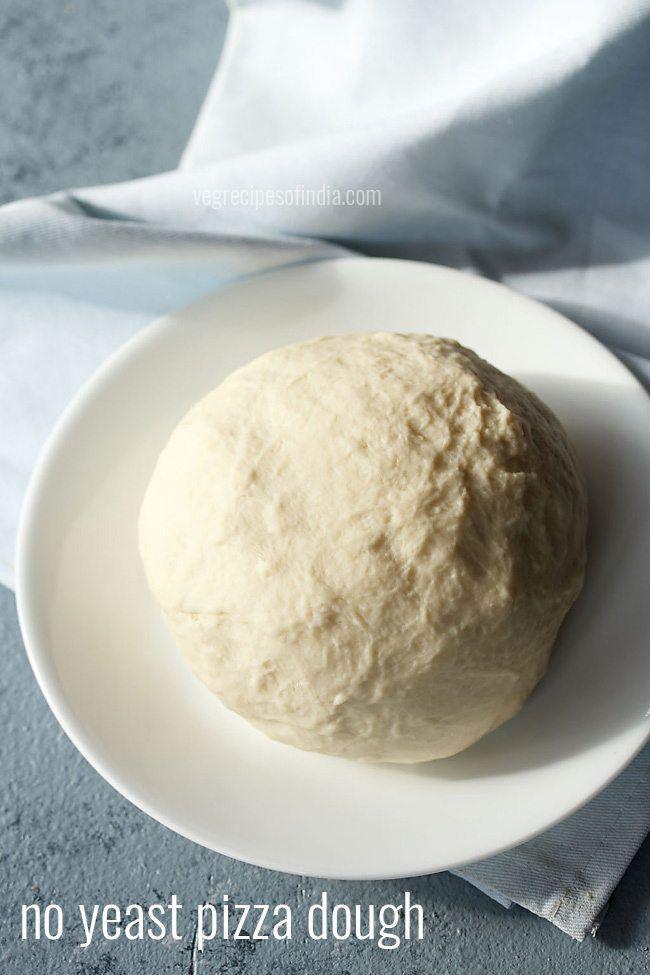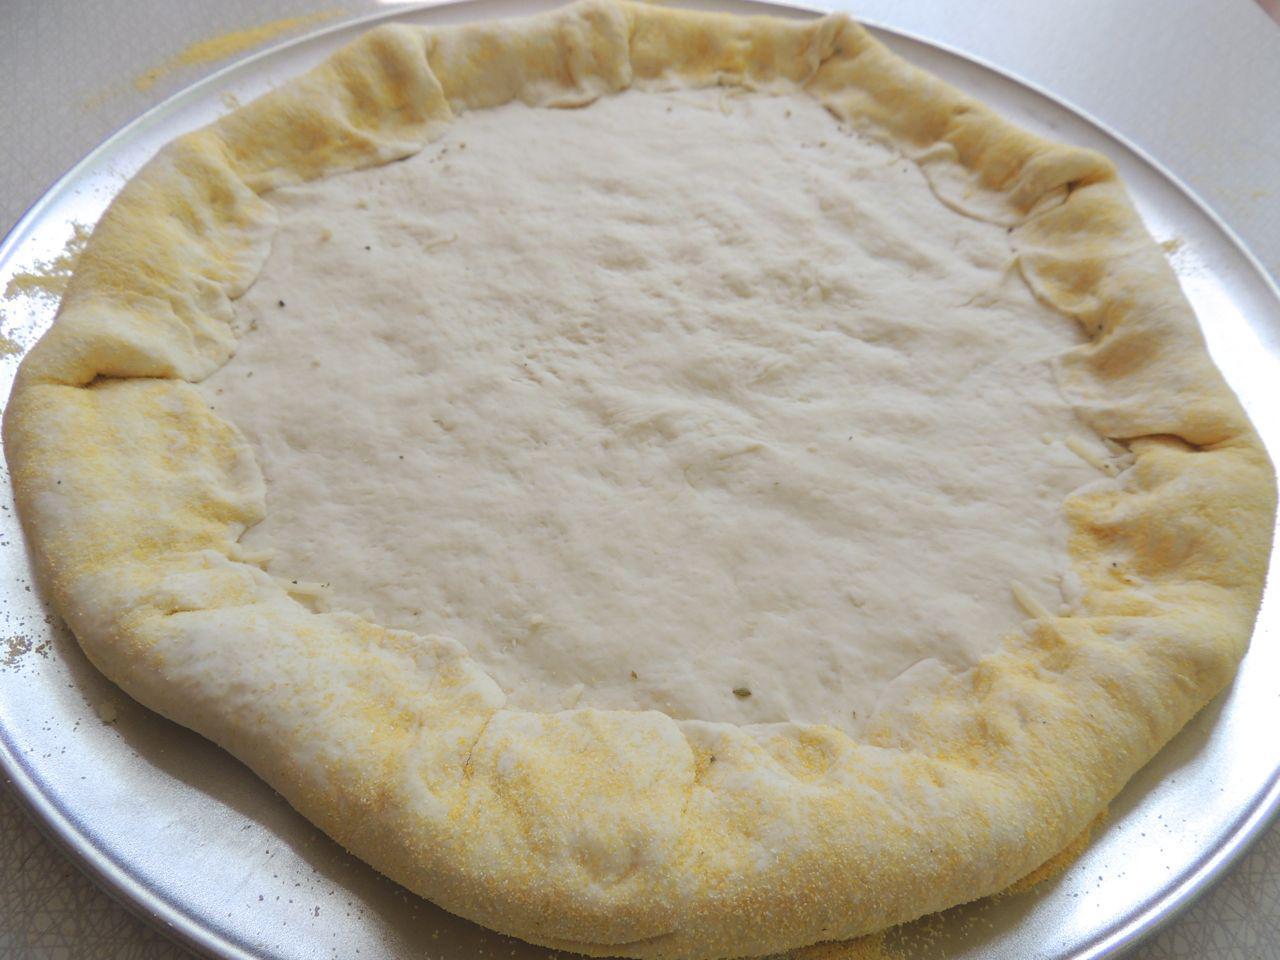The first image is the image on the left, the second image is the image on the right. Examine the images to the left and right. Is the description "One image shows a round ball of dough on a white plate that rests on a white cloth, and the other image shows a flattened round dough shape." accurate? Answer yes or no. Yes. 